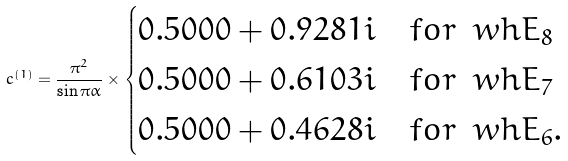<formula> <loc_0><loc_0><loc_500><loc_500>c ^ { ( 1 ) } = \frac { \pi ^ { 2 } } { \sin \pi \alpha } \times \begin{cases} 0 . 5 0 0 0 + 0 . 9 2 8 1 i \quad f o r \, \ w h { E } _ { 8 } \\ 0 . 5 0 0 0 + 0 . 6 1 0 3 i \quad f o r \, \ w h { E } _ { 7 } \\ 0 . 5 0 0 0 + 0 . 4 6 2 8 i \quad f o r \, \ w h { E } _ { 6 } . \end{cases}</formula> 